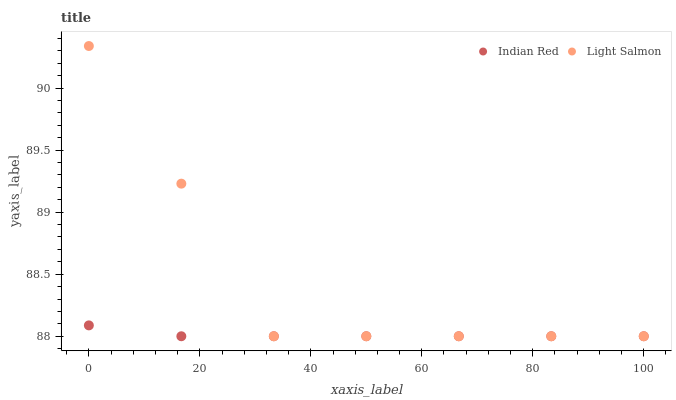Does Indian Red have the minimum area under the curve?
Answer yes or no. Yes. Does Light Salmon have the maximum area under the curve?
Answer yes or no. Yes. Does Indian Red have the maximum area under the curve?
Answer yes or no. No. Is Indian Red the smoothest?
Answer yes or no. Yes. Is Light Salmon the roughest?
Answer yes or no. Yes. Is Indian Red the roughest?
Answer yes or no. No. Does Light Salmon have the lowest value?
Answer yes or no. Yes. Does Light Salmon have the highest value?
Answer yes or no. Yes. Does Indian Red have the highest value?
Answer yes or no. No. Does Indian Red intersect Light Salmon?
Answer yes or no. Yes. Is Indian Red less than Light Salmon?
Answer yes or no. No. Is Indian Red greater than Light Salmon?
Answer yes or no. No. 